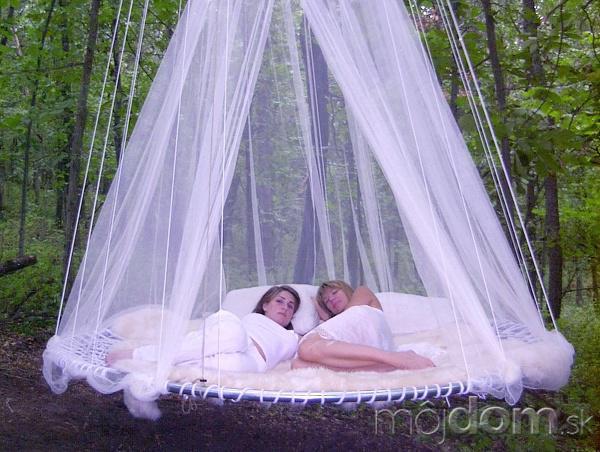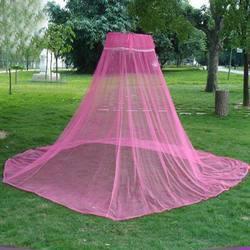The first image is the image on the left, the second image is the image on the right. Given the left and right images, does the statement "the mosquito net on the right is round" hold true? Answer yes or no. No. 